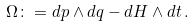<formula> <loc_0><loc_0><loc_500><loc_500>\Omega \colon = d p \wedge d q - d H \wedge d t \, .</formula> 